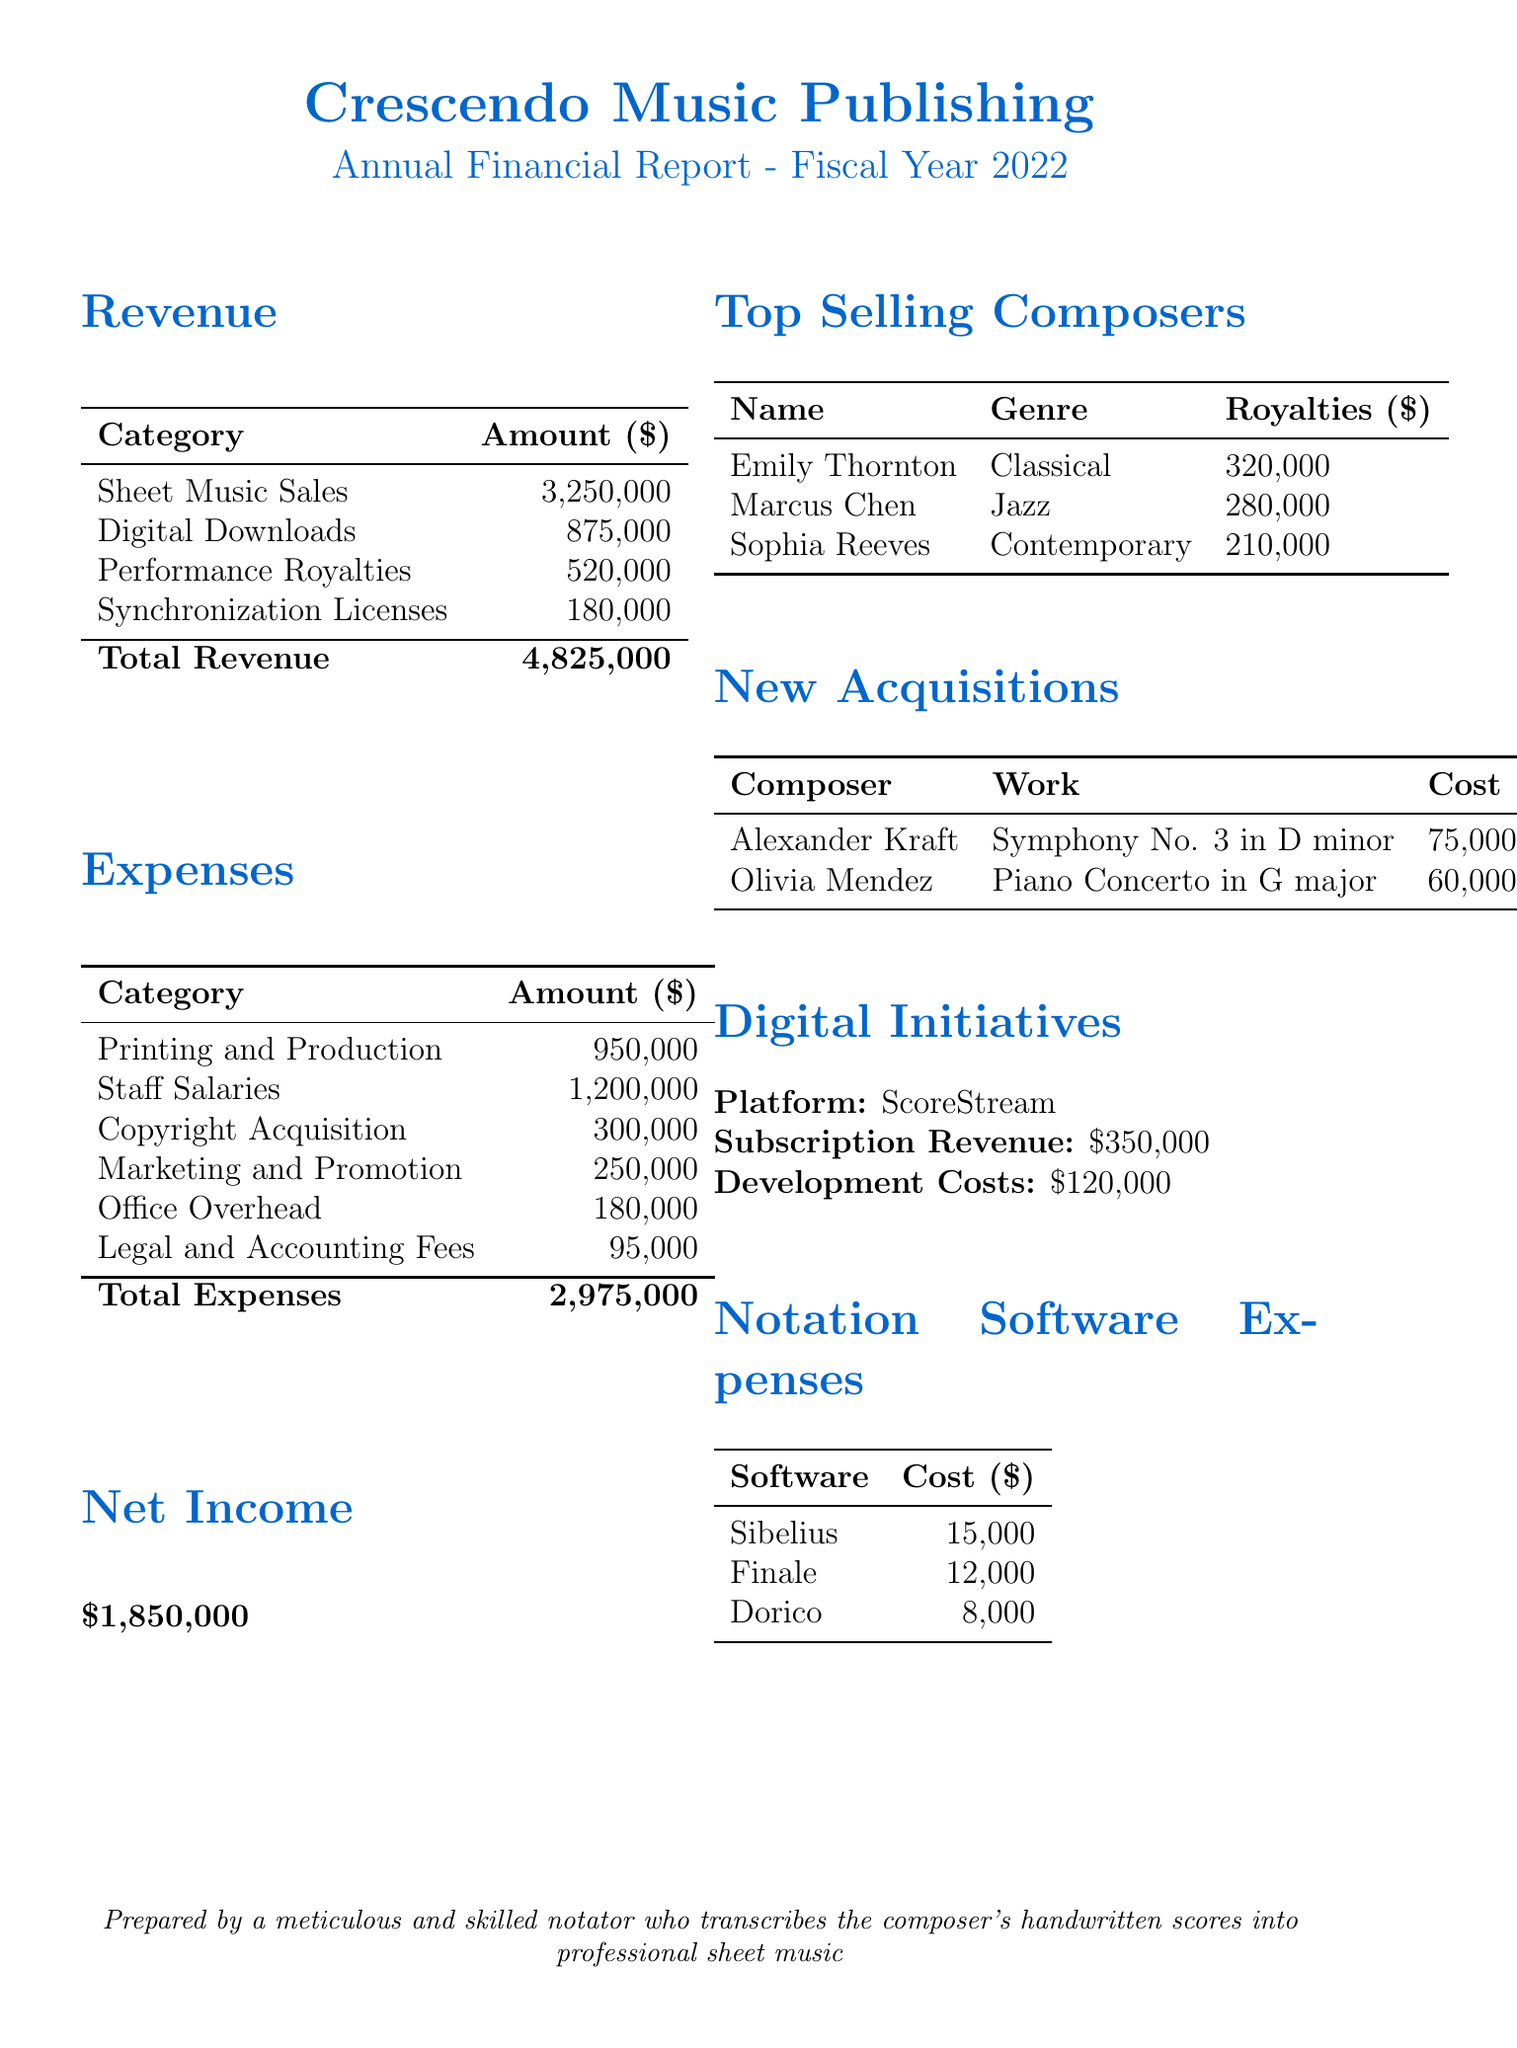what is the total revenue? The total revenue is the sum of all revenue sources in the document: 3,250,000 + 875,000 + 520,000 + 180,000 = 4,825,000.
Answer: 4,825,000 what is the largest expense category? The largest expense category is identified in the expenses section, which is staff salaries at 1,200,000.
Answer: staff salaries who earned the most in royalties? The top-selling composer who earned the most in royalties is listed in the top-selling composers section, which is Emily Thornton with 320,000.
Answer: Emily Thornton what were the development costs for digital initiatives? The development costs for digital initiatives are specifically mentioned in the digital initiatives section of the document as 120,000.
Answer: 120,000 how many composers were newly acquired? The document lists two new acquisitions in the new acquisitions section.
Answer: 2 what is the total amount spent on notation software? The total amount spent on notation software can be calculated by adding the costs listed for each software: 15,000 + 12,000 + 8,000 = 35,000.
Answer: 35,000 what is the genre of Marcus Chen? The genre associated with Marcus Chen is mentioned in the top-selling composers section as jazz.
Answer: Jazz what is the net income for the fiscal year? The net income is shown in the net income section, which is the total revenue minus total expenses: 4,825,000 - 2,975,000 = 1,850,000.
Answer: 1,850,000 which platform is mentioned for digital initiatives? The document specifies that the online sheet music platform for digital initiatives is ScoreStream.
Answer: ScoreStream 